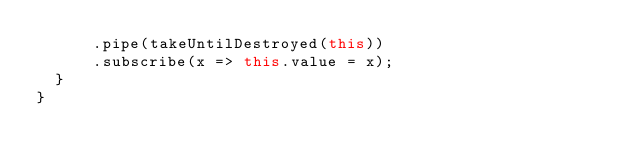<code> <loc_0><loc_0><loc_500><loc_500><_TypeScript_>      .pipe(takeUntilDestroyed(this))
      .subscribe(x => this.value = x);
  }
}
</code> 